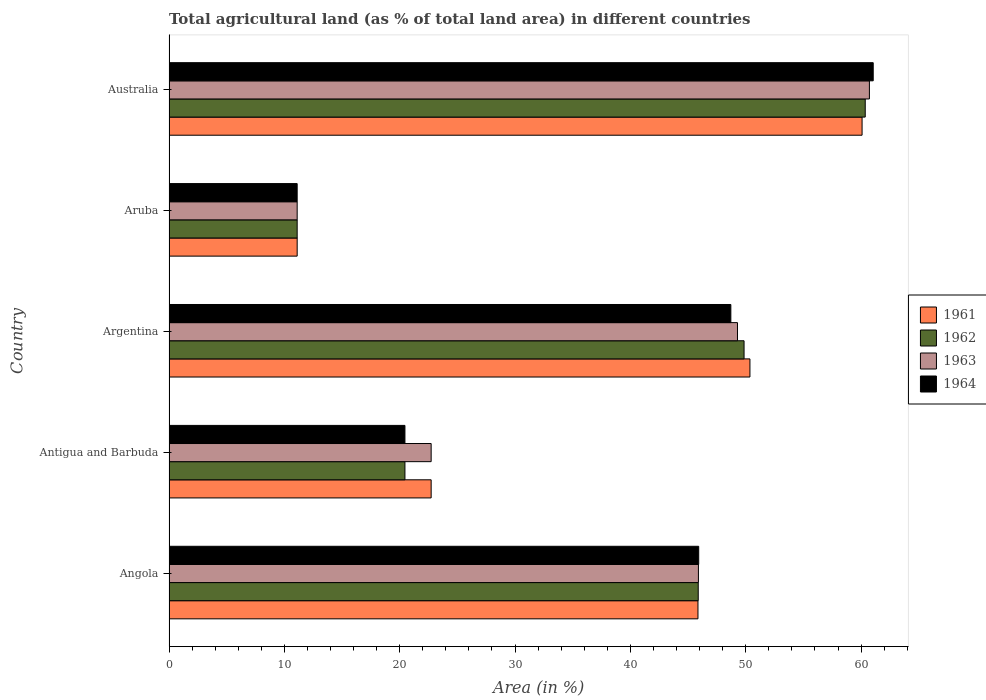Are the number of bars per tick equal to the number of legend labels?
Provide a short and direct response. Yes. How many bars are there on the 4th tick from the top?
Offer a terse response. 4. How many bars are there on the 1st tick from the bottom?
Keep it short and to the point. 4. In how many cases, is the number of bars for a given country not equal to the number of legend labels?
Make the answer very short. 0. What is the percentage of agricultural land in 1961 in Antigua and Barbuda?
Your response must be concise. 22.73. Across all countries, what is the maximum percentage of agricultural land in 1962?
Offer a terse response. 60.36. Across all countries, what is the minimum percentage of agricultural land in 1964?
Give a very brief answer. 11.11. In which country was the percentage of agricultural land in 1964 minimum?
Your response must be concise. Aruba. What is the total percentage of agricultural land in 1963 in the graph?
Provide a succinct answer. 189.74. What is the difference between the percentage of agricultural land in 1962 in Argentina and that in Aruba?
Offer a very short reply. 38.74. What is the difference between the percentage of agricultural land in 1962 in Australia and the percentage of agricultural land in 1963 in Angola?
Your answer should be compact. 14.46. What is the average percentage of agricultural land in 1964 per country?
Ensure brevity in your answer.  37.45. What is the difference between the percentage of agricultural land in 1963 and percentage of agricultural land in 1964 in Angola?
Ensure brevity in your answer.  -0.02. In how many countries, is the percentage of agricultural land in 1962 greater than 12 %?
Your response must be concise. 4. What is the ratio of the percentage of agricultural land in 1964 in Angola to that in Argentina?
Keep it short and to the point. 0.94. What is the difference between the highest and the second highest percentage of agricultural land in 1962?
Offer a terse response. 10.5. What is the difference between the highest and the lowest percentage of agricultural land in 1963?
Ensure brevity in your answer.  49.61. What does the 1st bar from the top in Angola represents?
Make the answer very short. 1964. What does the 1st bar from the bottom in Australia represents?
Make the answer very short. 1961. How many bars are there?
Give a very brief answer. 20. How many countries are there in the graph?
Make the answer very short. 5. Does the graph contain grids?
Give a very brief answer. No. How many legend labels are there?
Provide a short and direct response. 4. How are the legend labels stacked?
Provide a short and direct response. Vertical. What is the title of the graph?
Give a very brief answer. Total agricultural land (as % of total land area) in different countries. What is the label or title of the X-axis?
Give a very brief answer. Area (in %). What is the label or title of the Y-axis?
Provide a succinct answer. Country. What is the Area (in %) in 1961 in Angola?
Make the answer very short. 45.86. What is the Area (in %) of 1962 in Angola?
Offer a very short reply. 45.88. What is the Area (in %) of 1963 in Angola?
Give a very brief answer. 45.9. What is the Area (in %) in 1964 in Angola?
Your answer should be very brief. 45.92. What is the Area (in %) in 1961 in Antigua and Barbuda?
Your response must be concise. 22.73. What is the Area (in %) in 1962 in Antigua and Barbuda?
Ensure brevity in your answer.  20.45. What is the Area (in %) in 1963 in Antigua and Barbuda?
Keep it short and to the point. 22.73. What is the Area (in %) of 1964 in Antigua and Barbuda?
Ensure brevity in your answer.  20.45. What is the Area (in %) of 1961 in Argentina?
Ensure brevity in your answer.  50.36. What is the Area (in %) in 1962 in Argentina?
Ensure brevity in your answer.  49.85. What is the Area (in %) of 1963 in Argentina?
Your answer should be compact. 49.28. What is the Area (in %) of 1964 in Argentina?
Ensure brevity in your answer.  48.71. What is the Area (in %) of 1961 in Aruba?
Make the answer very short. 11.11. What is the Area (in %) in 1962 in Aruba?
Provide a succinct answer. 11.11. What is the Area (in %) in 1963 in Aruba?
Ensure brevity in your answer.  11.11. What is the Area (in %) of 1964 in Aruba?
Your answer should be compact. 11.11. What is the Area (in %) in 1961 in Australia?
Ensure brevity in your answer.  60.08. What is the Area (in %) of 1962 in Australia?
Your response must be concise. 60.36. What is the Area (in %) in 1963 in Australia?
Your answer should be compact. 60.72. What is the Area (in %) in 1964 in Australia?
Offer a very short reply. 61.05. Across all countries, what is the maximum Area (in %) in 1961?
Give a very brief answer. 60.08. Across all countries, what is the maximum Area (in %) in 1962?
Give a very brief answer. 60.36. Across all countries, what is the maximum Area (in %) of 1963?
Your response must be concise. 60.72. Across all countries, what is the maximum Area (in %) in 1964?
Your answer should be compact. 61.05. Across all countries, what is the minimum Area (in %) of 1961?
Offer a terse response. 11.11. Across all countries, what is the minimum Area (in %) in 1962?
Your answer should be very brief. 11.11. Across all countries, what is the minimum Area (in %) of 1963?
Provide a short and direct response. 11.11. Across all countries, what is the minimum Area (in %) of 1964?
Your answer should be compact. 11.11. What is the total Area (in %) of 1961 in the graph?
Ensure brevity in your answer.  190.14. What is the total Area (in %) in 1962 in the graph?
Ensure brevity in your answer.  187.66. What is the total Area (in %) in 1963 in the graph?
Make the answer very short. 189.74. What is the total Area (in %) in 1964 in the graph?
Offer a very short reply. 187.24. What is the difference between the Area (in %) in 1961 in Angola and that in Antigua and Barbuda?
Give a very brief answer. 23.13. What is the difference between the Area (in %) of 1962 in Angola and that in Antigua and Barbuda?
Your answer should be compact. 25.43. What is the difference between the Area (in %) in 1963 in Angola and that in Antigua and Barbuda?
Make the answer very short. 23.17. What is the difference between the Area (in %) in 1964 in Angola and that in Antigua and Barbuda?
Ensure brevity in your answer.  25.47. What is the difference between the Area (in %) of 1961 in Angola and that in Argentina?
Your response must be concise. -4.51. What is the difference between the Area (in %) in 1962 in Angola and that in Argentina?
Provide a short and direct response. -3.97. What is the difference between the Area (in %) of 1963 in Angola and that in Argentina?
Your answer should be very brief. -3.39. What is the difference between the Area (in %) in 1964 in Angola and that in Argentina?
Make the answer very short. -2.79. What is the difference between the Area (in %) in 1961 in Angola and that in Aruba?
Make the answer very short. 34.75. What is the difference between the Area (in %) of 1962 in Angola and that in Aruba?
Make the answer very short. 34.77. What is the difference between the Area (in %) of 1963 in Angola and that in Aruba?
Provide a short and direct response. 34.79. What is the difference between the Area (in %) of 1964 in Angola and that in Aruba?
Keep it short and to the point. 34.81. What is the difference between the Area (in %) in 1961 in Angola and that in Australia?
Provide a short and direct response. -14.23. What is the difference between the Area (in %) of 1962 in Angola and that in Australia?
Offer a terse response. -14.48. What is the difference between the Area (in %) of 1963 in Angola and that in Australia?
Give a very brief answer. -14.82. What is the difference between the Area (in %) in 1964 in Angola and that in Australia?
Provide a short and direct response. -15.13. What is the difference between the Area (in %) of 1961 in Antigua and Barbuda and that in Argentina?
Your answer should be compact. -27.64. What is the difference between the Area (in %) of 1962 in Antigua and Barbuda and that in Argentina?
Provide a succinct answer. -29.4. What is the difference between the Area (in %) of 1963 in Antigua and Barbuda and that in Argentina?
Provide a short and direct response. -26.56. What is the difference between the Area (in %) of 1964 in Antigua and Barbuda and that in Argentina?
Keep it short and to the point. -28.25. What is the difference between the Area (in %) in 1961 in Antigua and Barbuda and that in Aruba?
Provide a succinct answer. 11.62. What is the difference between the Area (in %) of 1962 in Antigua and Barbuda and that in Aruba?
Keep it short and to the point. 9.34. What is the difference between the Area (in %) of 1963 in Antigua and Barbuda and that in Aruba?
Your answer should be very brief. 11.62. What is the difference between the Area (in %) of 1964 in Antigua and Barbuda and that in Aruba?
Keep it short and to the point. 9.34. What is the difference between the Area (in %) in 1961 in Antigua and Barbuda and that in Australia?
Your response must be concise. -37.36. What is the difference between the Area (in %) of 1962 in Antigua and Barbuda and that in Australia?
Keep it short and to the point. -39.9. What is the difference between the Area (in %) of 1963 in Antigua and Barbuda and that in Australia?
Provide a succinct answer. -37.99. What is the difference between the Area (in %) in 1964 in Antigua and Barbuda and that in Australia?
Your answer should be compact. -40.6. What is the difference between the Area (in %) in 1961 in Argentina and that in Aruba?
Your answer should be very brief. 39.25. What is the difference between the Area (in %) of 1962 in Argentina and that in Aruba?
Offer a terse response. 38.74. What is the difference between the Area (in %) of 1963 in Argentina and that in Aruba?
Make the answer very short. 38.17. What is the difference between the Area (in %) in 1964 in Argentina and that in Aruba?
Make the answer very short. 37.6. What is the difference between the Area (in %) in 1961 in Argentina and that in Australia?
Your response must be concise. -9.72. What is the difference between the Area (in %) in 1962 in Argentina and that in Australia?
Your answer should be compact. -10.5. What is the difference between the Area (in %) of 1963 in Argentina and that in Australia?
Ensure brevity in your answer.  -11.44. What is the difference between the Area (in %) of 1964 in Argentina and that in Australia?
Your response must be concise. -12.34. What is the difference between the Area (in %) in 1961 in Aruba and that in Australia?
Your response must be concise. -48.97. What is the difference between the Area (in %) of 1962 in Aruba and that in Australia?
Offer a very short reply. -49.25. What is the difference between the Area (in %) of 1963 in Aruba and that in Australia?
Give a very brief answer. -49.61. What is the difference between the Area (in %) in 1964 in Aruba and that in Australia?
Your response must be concise. -49.94. What is the difference between the Area (in %) in 1961 in Angola and the Area (in %) in 1962 in Antigua and Barbuda?
Provide a short and direct response. 25.4. What is the difference between the Area (in %) of 1961 in Angola and the Area (in %) of 1963 in Antigua and Barbuda?
Provide a succinct answer. 23.13. What is the difference between the Area (in %) of 1961 in Angola and the Area (in %) of 1964 in Antigua and Barbuda?
Offer a very short reply. 25.4. What is the difference between the Area (in %) in 1962 in Angola and the Area (in %) in 1963 in Antigua and Barbuda?
Keep it short and to the point. 23.15. What is the difference between the Area (in %) in 1962 in Angola and the Area (in %) in 1964 in Antigua and Barbuda?
Make the answer very short. 25.43. What is the difference between the Area (in %) of 1963 in Angola and the Area (in %) of 1964 in Antigua and Barbuda?
Make the answer very short. 25.44. What is the difference between the Area (in %) in 1961 in Angola and the Area (in %) in 1962 in Argentina?
Ensure brevity in your answer.  -4. What is the difference between the Area (in %) in 1961 in Angola and the Area (in %) in 1963 in Argentina?
Make the answer very short. -3.43. What is the difference between the Area (in %) of 1961 in Angola and the Area (in %) of 1964 in Argentina?
Provide a succinct answer. -2.85. What is the difference between the Area (in %) in 1962 in Angola and the Area (in %) in 1963 in Argentina?
Keep it short and to the point. -3.4. What is the difference between the Area (in %) in 1962 in Angola and the Area (in %) in 1964 in Argentina?
Your answer should be very brief. -2.83. What is the difference between the Area (in %) of 1963 in Angola and the Area (in %) of 1964 in Argentina?
Offer a very short reply. -2.81. What is the difference between the Area (in %) in 1961 in Angola and the Area (in %) in 1962 in Aruba?
Keep it short and to the point. 34.75. What is the difference between the Area (in %) in 1961 in Angola and the Area (in %) in 1963 in Aruba?
Keep it short and to the point. 34.75. What is the difference between the Area (in %) of 1961 in Angola and the Area (in %) of 1964 in Aruba?
Offer a terse response. 34.75. What is the difference between the Area (in %) of 1962 in Angola and the Area (in %) of 1963 in Aruba?
Your response must be concise. 34.77. What is the difference between the Area (in %) of 1962 in Angola and the Area (in %) of 1964 in Aruba?
Your answer should be compact. 34.77. What is the difference between the Area (in %) of 1963 in Angola and the Area (in %) of 1964 in Aruba?
Your answer should be compact. 34.79. What is the difference between the Area (in %) of 1961 in Angola and the Area (in %) of 1962 in Australia?
Provide a succinct answer. -14.5. What is the difference between the Area (in %) of 1961 in Angola and the Area (in %) of 1963 in Australia?
Keep it short and to the point. -14.86. What is the difference between the Area (in %) of 1961 in Angola and the Area (in %) of 1964 in Australia?
Your response must be concise. -15.19. What is the difference between the Area (in %) in 1962 in Angola and the Area (in %) in 1963 in Australia?
Provide a succinct answer. -14.84. What is the difference between the Area (in %) of 1962 in Angola and the Area (in %) of 1964 in Australia?
Provide a succinct answer. -15.17. What is the difference between the Area (in %) in 1963 in Angola and the Area (in %) in 1964 in Australia?
Provide a succinct answer. -15.15. What is the difference between the Area (in %) in 1961 in Antigua and Barbuda and the Area (in %) in 1962 in Argentina?
Your answer should be very brief. -27.13. What is the difference between the Area (in %) in 1961 in Antigua and Barbuda and the Area (in %) in 1963 in Argentina?
Give a very brief answer. -26.56. What is the difference between the Area (in %) in 1961 in Antigua and Barbuda and the Area (in %) in 1964 in Argentina?
Your response must be concise. -25.98. What is the difference between the Area (in %) in 1962 in Antigua and Barbuda and the Area (in %) in 1963 in Argentina?
Make the answer very short. -28.83. What is the difference between the Area (in %) in 1962 in Antigua and Barbuda and the Area (in %) in 1964 in Argentina?
Give a very brief answer. -28.25. What is the difference between the Area (in %) of 1963 in Antigua and Barbuda and the Area (in %) of 1964 in Argentina?
Ensure brevity in your answer.  -25.98. What is the difference between the Area (in %) in 1961 in Antigua and Barbuda and the Area (in %) in 1962 in Aruba?
Make the answer very short. 11.62. What is the difference between the Area (in %) of 1961 in Antigua and Barbuda and the Area (in %) of 1963 in Aruba?
Keep it short and to the point. 11.62. What is the difference between the Area (in %) of 1961 in Antigua and Barbuda and the Area (in %) of 1964 in Aruba?
Keep it short and to the point. 11.62. What is the difference between the Area (in %) in 1962 in Antigua and Barbuda and the Area (in %) in 1963 in Aruba?
Make the answer very short. 9.34. What is the difference between the Area (in %) in 1962 in Antigua and Barbuda and the Area (in %) in 1964 in Aruba?
Ensure brevity in your answer.  9.34. What is the difference between the Area (in %) in 1963 in Antigua and Barbuda and the Area (in %) in 1964 in Aruba?
Keep it short and to the point. 11.62. What is the difference between the Area (in %) of 1961 in Antigua and Barbuda and the Area (in %) of 1962 in Australia?
Provide a succinct answer. -37.63. What is the difference between the Area (in %) in 1961 in Antigua and Barbuda and the Area (in %) in 1963 in Australia?
Your answer should be very brief. -37.99. What is the difference between the Area (in %) of 1961 in Antigua and Barbuda and the Area (in %) of 1964 in Australia?
Make the answer very short. -38.32. What is the difference between the Area (in %) of 1962 in Antigua and Barbuda and the Area (in %) of 1963 in Australia?
Your answer should be compact. -40.27. What is the difference between the Area (in %) in 1962 in Antigua and Barbuda and the Area (in %) in 1964 in Australia?
Your response must be concise. -40.6. What is the difference between the Area (in %) in 1963 in Antigua and Barbuda and the Area (in %) in 1964 in Australia?
Provide a succinct answer. -38.32. What is the difference between the Area (in %) of 1961 in Argentina and the Area (in %) of 1962 in Aruba?
Make the answer very short. 39.25. What is the difference between the Area (in %) in 1961 in Argentina and the Area (in %) in 1963 in Aruba?
Provide a short and direct response. 39.25. What is the difference between the Area (in %) of 1961 in Argentina and the Area (in %) of 1964 in Aruba?
Provide a succinct answer. 39.25. What is the difference between the Area (in %) of 1962 in Argentina and the Area (in %) of 1963 in Aruba?
Your answer should be very brief. 38.74. What is the difference between the Area (in %) of 1962 in Argentina and the Area (in %) of 1964 in Aruba?
Make the answer very short. 38.74. What is the difference between the Area (in %) of 1963 in Argentina and the Area (in %) of 1964 in Aruba?
Offer a terse response. 38.17. What is the difference between the Area (in %) of 1961 in Argentina and the Area (in %) of 1962 in Australia?
Ensure brevity in your answer.  -9.99. What is the difference between the Area (in %) in 1961 in Argentina and the Area (in %) in 1963 in Australia?
Provide a short and direct response. -10.36. What is the difference between the Area (in %) in 1961 in Argentina and the Area (in %) in 1964 in Australia?
Make the answer very short. -10.69. What is the difference between the Area (in %) in 1962 in Argentina and the Area (in %) in 1963 in Australia?
Make the answer very short. -10.87. What is the difference between the Area (in %) of 1962 in Argentina and the Area (in %) of 1964 in Australia?
Keep it short and to the point. -11.2. What is the difference between the Area (in %) in 1963 in Argentina and the Area (in %) in 1964 in Australia?
Your answer should be compact. -11.77. What is the difference between the Area (in %) in 1961 in Aruba and the Area (in %) in 1962 in Australia?
Your answer should be very brief. -49.25. What is the difference between the Area (in %) in 1961 in Aruba and the Area (in %) in 1963 in Australia?
Your answer should be very brief. -49.61. What is the difference between the Area (in %) in 1961 in Aruba and the Area (in %) in 1964 in Australia?
Your response must be concise. -49.94. What is the difference between the Area (in %) of 1962 in Aruba and the Area (in %) of 1963 in Australia?
Provide a succinct answer. -49.61. What is the difference between the Area (in %) in 1962 in Aruba and the Area (in %) in 1964 in Australia?
Provide a short and direct response. -49.94. What is the difference between the Area (in %) in 1963 in Aruba and the Area (in %) in 1964 in Australia?
Your response must be concise. -49.94. What is the average Area (in %) in 1961 per country?
Your answer should be compact. 38.03. What is the average Area (in %) in 1962 per country?
Ensure brevity in your answer.  37.53. What is the average Area (in %) of 1963 per country?
Give a very brief answer. 37.95. What is the average Area (in %) in 1964 per country?
Keep it short and to the point. 37.45. What is the difference between the Area (in %) in 1961 and Area (in %) in 1962 in Angola?
Provide a succinct answer. -0.02. What is the difference between the Area (in %) in 1961 and Area (in %) in 1963 in Angola?
Provide a short and direct response. -0.04. What is the difference between the Area (in %) in 1961 and Area (in %) in 1964 in Angola?
Give a very brief answer. -0.06. What is the difference between the Area (in %) in 1962 and Area (in %) in 1963 in Angola?
Ensure brevity in your answer.  -0.02. What is the difference between the Area (in %) in 1962 and Area (in %) in 1964 in Angola?
Ensure brevity in your answer.  -0.04. What is the difference between the Area (in %) of 1963 and Area (in %) of 1964 in Angola?
Offer a terse response. -0.02. What is the difference between the Area (in %) of 1961 and Area (in %) of 1962 in Antigua and Barbuda?
Offer a terse response. 2.27. What is the difference between the Area (in %) of 1961 and Area (in %) of 1963 in Antigua and Barbuda?
Your response must be concise. 0. What is the difference between the Area (in %) in 1961 and Area (in %) in 1964 in Antigua and Barbuda?
Offer a terse response. 2.27. What is the difference between the Area (in %) in 1962 and Area (in %) in 1963 in Antigua and Barbuda?
Ensure brevity in your answer.  -2.27. What is the difference between the Area (in %) in 1963 and Area (in %) in 1964 in Antigua and Barbuda?
Offer a terse response. 2.27. What is the difference between the Area (in %) in 1961 and Area (in %) in 1962 in Argentina?
Your response must be concise. 0.51. What is the difference between the Area (in %) in 1961 and Area (in %) in 1963 in Argentina?
Your answer should be very brief. 1.08. What is the difference between the Area (in %) in 1961 and Area (in %) in 1964 in Argentina?
Your answer should be very brief. 1.66. What is the difference between the Area (in %) in 1962 and Area (in %) in 1963 in Argentina?
Offer a terse response. 0.57. What is the difference between the Area (in %) of 1962 and Area (in %) of 1964 in Argentina?
Give a very brief answer. 1.15. What is the difference between the Area (in %) of 1963 and Area (in %) of 1964 in Argentina?
Keep it short and to the point. 0.58. What is the difference between the Area (in %) in 1961 and Area (in %) in 1962 in Aruba?
Ensure brevity in your answer.  0. What is the difference between the Area (in %) in 1961 and Area (in %) in 1963 in Aruba?
Give a very brief answer. 0. What is the difference between the Area (in %) in 1962 and Area (in %) in 1963 in Aruba?
Give a very brief answer. 0. What is the difference between the Area (in %) in 1963 and Area (in %) in 1964 in Aruba?
Provide a short and direct response. 0. What is the difference between the Area (in %) of 1961 and Area (in %) of 1962 in Australia?
Provide a short and direct response. -0.27. What is the difference between the Area (in %) in 1961 and Area (in %) in 1963 in Australia?
Offer a terse response. -0.64. What is the difference between the Area (in %) of 1961 and Area (in %) of 1964 in Australia?
Your answer should be very brief. -0.97. What is the difference between the Area (in %) in 1962 and Area (in %) in 1963 in Australia?
Provide a short and direct response. -0.36. What is the difference between the Area (in %) of 1962 and Area (in %) of 1964 in Australia?
Keep it short and to the point. -0.69. What is the difference between the Area (in %) in 1963 and Area (in %) in 1964 in Australia?
Provide a succinct answer. -0.33. What is the ratio of the Area (in %) of 1961 in Angola to that in Antigua and Barbuda?
Keep it short and to the point. 2.02. What is the ratio of the Area (in %) in 1962 in Angola to that in Antigua and Barbuda?
Your answer should be very brief. 2.24. What is the ratio of the Area (in %) in 1963 in Angola to that in Antigua and Barbuda?
Provide a succinct answer. 2.02. What is the ratio of the Area (in %) in 1964 in Angola to that in Antigua and Barbuda?
Keep it short and to the point. 2.25. What is the ratio of the Area (in %) in 1961 in Angola to that in Argentina?
Keep it short and to the point. 0.91. What is the ratio of the Area (in %) of 1962 in Angola to that in Argentina?
Give a very brief answer. 0.92. What is the ratio of the Area (in %) of 1963 in Angola to that in Argentina?
Offer a very short reply. 0.93. What is the ratio of the Area (in %) of 1964 in Angola to that in Argentina?
Provide a short and direct response. 0.94. What is the ratio of the Area (in %) in 1961 in Angola to that in Aruba?
Give a very brief answer. 4.13. What is the ratio of the Area (in %) of 1962 in Angola to that in Aruba?
Offer a very short reply. 4.13. What is the ratio of the Area (in %) of 1963 in Angola to that in Aruba?
Keep it short and to the point. 4.13. What is the ratio of the Area (in %) in 1964 in Angola to that in Aruba?
Offer a very short reply. 4.13. What is the ratio of the Area (in %) in 1961 in Angola to that in Australia?
Your answer should be very brief. 0.76. What is the ratio of the Area (in %) of 1962 in Angola to that in Australia?
Your answer should be compact. 0.76. What is the ratio of the Area (in %) in 1963 in Angola to that in Australia?
Provide a succinct answer. 0.76. What is the ratio of the Area (in %) of 1964 in Angola to that in Australia?
Your response must be concise. 0.75. What is the ratio of the Area (in %) in 1961 in Antigua and Barbuda to that in Argentina?
Your answer should be very brief. 0.45. What is the ratio of the Area (in %) of 1962 in Antigua and Barbuda to that in Argentina?
Offer a terse response. 0.41. What is the ratio of the Area (in %) of 1963 in Antigua and Barbuda to that in Argentina?
Your response must be concise. 0.46. What is the ratio of the Area (in %) of 1964 in Antigua and Barbuda to that in Argentina?
Keep it short and to the point. 0.42. What is the ratio of the Area (in %) of 1961 in Antigua and Barbuda to that in Aruba?
Your answer should be compact. 2.05. What is the ratio of the Area (in %) in 1962 in Antigua and Barbuda to that in Aruba?
Give a very brief answer. 1.84. What is the ratio of the Area (in %) of 1963 in Antigua and Barbuda to that in Aruba?
Give a very brief answer. 2.05. What is the ratio of the Area (in %) of 1964 in Antigua and Barbuda to that in Aruba?
Offer a very short reply. 1.84. What is the ratio of the Area (in %) of 1961 in Antigua and Barbuda to that in Australia?
Provide a succinct answer. 0.38. What is the ratio of the Area (in %) in 1962 in Antigua and Barbuda to that in Australia?
Your response must be concise. 0.34. What is the ratio of the Area (in %) of 1963 in Antigua and Barbuda to that in Australia?
Provide a succinct answer. 0.37. What is the ratio of the Area (in %) of 1964 in Antigua and Barbuda to that in Australia?
Offer a terse response. 0.34. What is the ratio of the Area (in %) in 1961 in Argentina to that in Aruba?
Provide a short and direct response. 4.53. What is the ratio of the Area (in %) of 1962 in Argentina to that in Aruba?
Your answer should be very brief. 4.49. What is the ratio of the Area (in %) in 1963 in Argentina to that in Aruba?
Your response must be concise. 4.44. What is the ratio of the Area (in %) of 1964 in Argentina to that in Aruba?
Provide a short and direct response. 4.38. What is the ratio of the Area (in %) in 1961 in Argentina to that in Australia?
Give a very brief answer. 0.84. What is the ratio of the Area (in %) in 1962 in Argentina to that in Australia?
Your response must be concise. 0.83. What is the ratio of the Area (in %) in 1963 in Argentina to that in Australia?
Give a very brief answer. 0.81. What is the ratio of the Area (in %) of 1964 in Argentina to that in Australia?
Your answer should be very brief. 0.8. What is the ratio of the Area (in %) in 1961 in Aruba to that in Australia?
Provide a succinct answer. 0.18. What is the ratio of the Area (in %) in 1962 in Aruba to that in Australia?
Offer a very short reply. 0.18. What is the ratio of the Area (in %) in 1963 in Aruba to that in Australia?
Make the answer very short. 0.18. What is the ratio of the Area (in %) of 1964 in Aruba to that in Australia?
Your answer should be compact. 0.18. What is the difference between the highest and the second highest Area (in %) in 1961?
Keep it short and to the point. 9.72. What is the difference between the highest and the second highest Area (in %) in 1962?
Your answer should be very brief. 10.5. What is the difference between the highest and the second highest Area (in %) in 1963?
Your answer should be very brief. 11.44. What is the difference between the highest and the second highest Area (in %) in 1964?
Offer a very short reply. 12.34. What is the difference between the highest and the lowest Area (in %) in 1961?
Your answer should be compact. 48.97. What is the difference between the highest and the lowest Area (in %) of 1962?
Give a very brief answer. 49.25. What is the difference between the highest and the lowest Area (in %) of 1963?
Offer a terse response. 49.61. What is the difference between the highest and the lowest Area (in %) in 1964?
Keep it short and to the point. 49.94. 